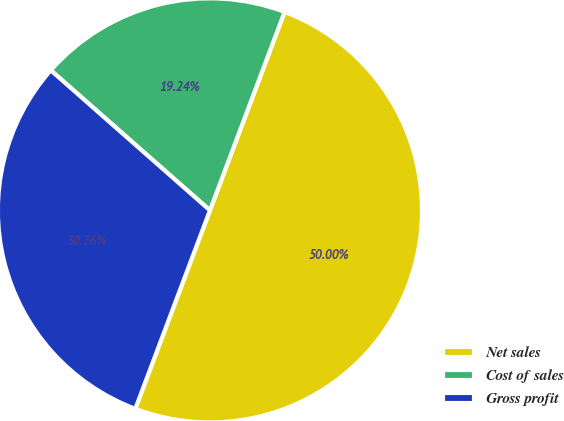Convert chart. <chart><loc_0><loc_0><loc_500><loc_500><pie_chart><fcel>Net sales<fcel>Cost of sales<fcel>Gross profit<nl><fcel>50.0%<fcel>19.24%<fcel>30.76%<nl></chart> 